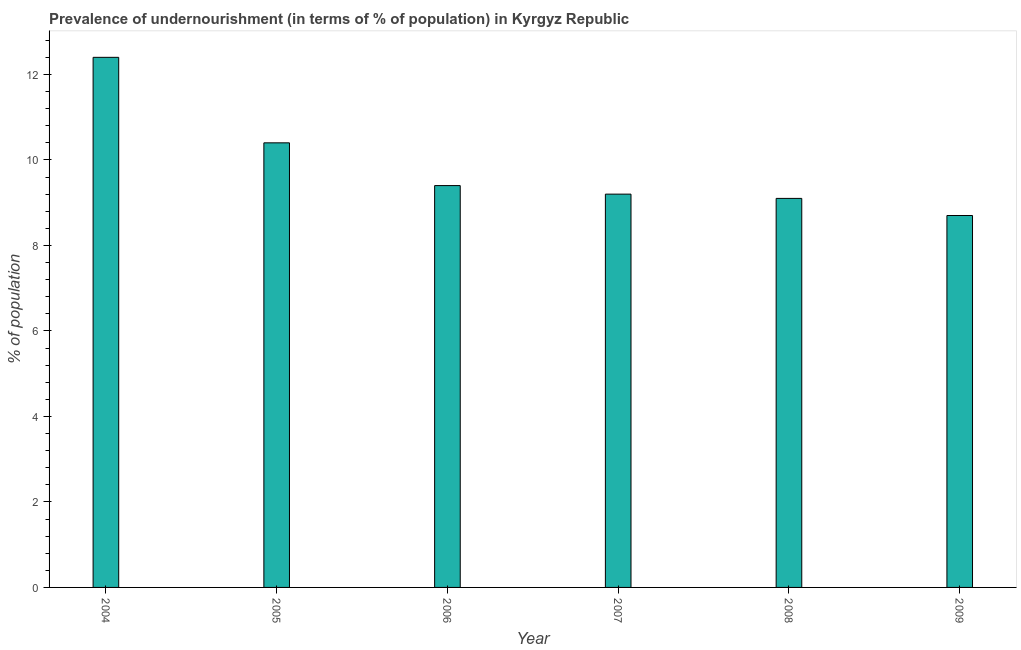What is the title of the graph?
Your response must be concise. Prevalence of undernourishment (in terms of % of population) in Kyrgyz Republic. What is the label or title of the X-axis?
Offer a very short reply. Year. What is the label or title of the Y-axis?
Offer a very short reply. % of population. Across all years, what is the minimum percentage of undernourished population?
Provide a succinct answer. 8.7. In which year was the percentage of undernourished population maximum?
Offer a very short reply. 2004. What is the sum of the percentage of undernourished population?
Keep it short and to the point. 59.2. What is the average percentage of undernourished population per year?
Keep it short and to the point. 9.87. What is the median percentage of undernourished population?
Ensure brevity in your answer.  9.3. In how many years, is the percentage of undernourished population greater than 11.2 %?
Your response must be concise. 1. Do a majority of the years between 2007 and 2004 (inclusive) have percentage of undernourished population greater than 2.4 %?
Make the answer very short. Yes. What is the ratio of the percentage of undernourished population in 2008 to that in 2009?
Your answer should be very brief. 1.05. Is the difference between the percentage of undernourished population in 2004 and 2006 greater than the difference between any two years?
Ensure brevity in your answer.  No. What is the difference between the highest and the lowest percentage of undernourished population?
Make the answer very short. 3.7. How many years are there in the graph?
Offer a very short reply. 6. What is the difference between two consecutive major ticks on the Y-axis?
Offer a very short reply. 2. Are the values on the major ticks of Y-axis written in scientific E-notation?
Your answer should be compact. No. What is the % of population of 2007?
Make the answer very short. 9.2. What is the % of population of 2009?
Your response must be concise. 8.7. What is the difference between the % of population in 2004 and 2008?
Your response must be concise. 3.3. What is the difference between the % of population in 2005 and 2006?
Give a very brief answer. 1. What is the difference between the % of population in 2005 and 2007?
Keep it short and to the point. 1.2. What is the difference between the % of population in 2006 and 2007?
Offer a terse response. 0.2. What is the difference between the % of population in 2006 and 2009?
Keep it short and to the point. 0.7. What is the difference between the % of population in 2007 and 2009?
Offer a terse response. 0.5. What is the difference between the % of population in 2008 and 2009?
Provide a succinct answer. 0.4. What is the ratio of the % of population in 2004 to that in 2005?
Your answer should be compact. 1.19. What is the ratio of the % of population in 2004 to that in 2006?
Your answer should be very brief. 1.32. What is the ratio of the % of population in 2004 to that in 2007?
Your answer should be very brief. 1.35. What is the ratio of the % of population in 2004 to that in 2008?
Keep it short and to the point. 1.36. What is the ratio of the % of population in 2004 to that in 2009?
Your answer should be compact. 1.43. What is the ratio of the % of population in 2005 to that in 2006?
Offer a very short reply. 1.11. What is the ratio of the % of population in 2005 to that in 2007?
Offer a terse response. 1.13. What is the ratio of the % of population in 2005 to that in 2008?
Give a very brief answer. 1.14. What is the ratio of the % of population in 2005 to that in 2009?
Your response must be concise. 1.2. What is the ratio of the % of population in 2006 to that in 2008?
Offer a terse response. 1.03. What is the ratio of the % of population in 2007 to that in 2009?
Give a very brief answer. 1.06. What is the ratio of the % of population in 2008 to that in 2009?
Your response must be concise. 1.05. 